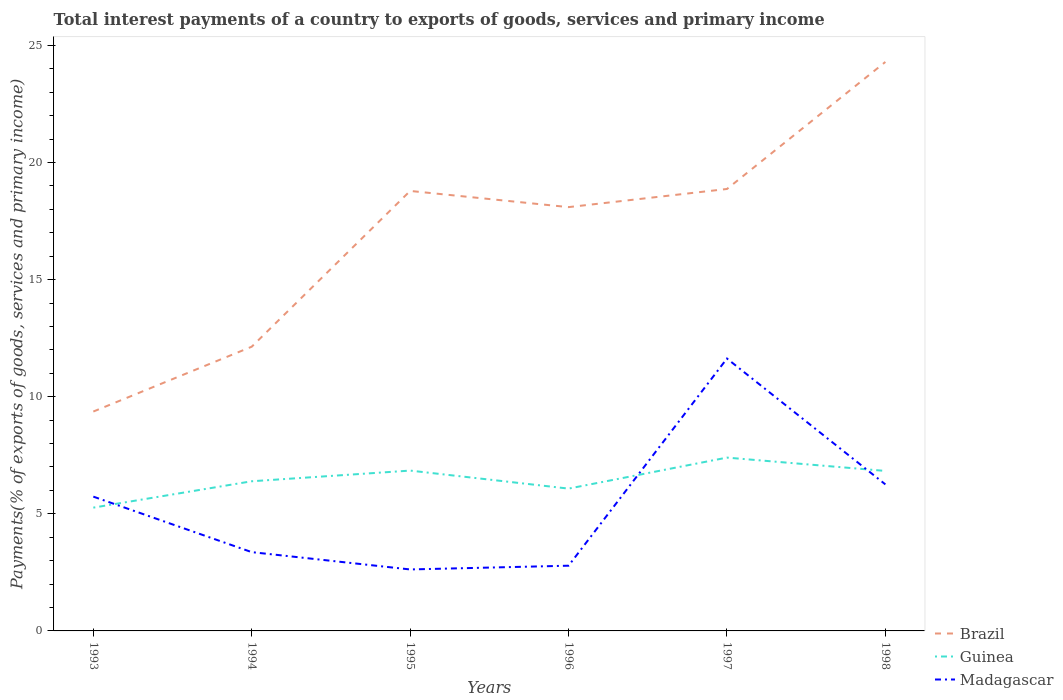Does the line corresponding to Brazil intersect with the line corresponding to Madagascar?
Provide a succinct answer. No. Is the number of lines equal to the number of legend labels?
Ensure brevity in your answer.  Yes. Across all years, what is the maximum total interest payments in Brazil?
Keep it short and to the point. 9.37. What is the total total interest payments in Guinea in the graph?
Your response must be concise. -1.13. What is the difference between the highest and the second highest total interest payments in Brazil?
Give a very brief answer. 14.93. How many lines are there?
Provide a short and direct response. 3. Does the graph contain grids?
Ensure brevity in your answer.  No. Where does the legend appear in the graph?
Provide a short and direct response. Bottom right. What is the title of the graph?
Your answer should be compact. Total interest payments of a country to exports of goods, services and primary income. What is the label or title of the Y-axis?
Your answer should be compact. Payments(% of exports of goods, services and primary income). What is the Payments(% of exports of goods, services and primary income) of Brazil in 1993?
Give a very brief answer. 9.37. What is the Payments(% of exports of goods, services and primary income) in Guinea in 1993?
Keep it short and to the point. 5.26. What is the Payments(% of exports of goods, services and primary income) of Madagascar in 1993?
Offer a very short reply. 5.73. What is the Payments(% of exports of goods, services and primary income) of Brazil in 1994?
Your answer should be very brief. 12.14. What is the Payments(% of exports of goods, services and primary income) of Guinea in 1994?
Keep it short and to the point. 6.39. What is the Payments(% of exports of goods, services and primary income) of Madagascar in 1994?
Provide a succinct answer. 3.36. What is the Payments(% of exports of goods, services and primary income) in Brazil in 1995?
Your answer should be very brief. 18.79. What is the Payments(% of exports of goods, services and primary income) in Guinea in 1995?
Your response must be concise. 6.85. What is the Payments(% of exports of goods, services and primary income) of Madagascar in 1995?
Your response must be concise. 2.62. What is the Payments(% of exports of goods, services and primary income) of Brazil in 1996?
Your answer should be very brief. 18.1. What is the Payments(% of exports of goods, services and primary income) of Guinea in 1996?
Give a very brief answer. 6.08. What is the Payments(% of exports of goods, services and primary income) in Madagascar in 1996?
Offer a very short reply. 2.78. What is the Payments(% of exports of goods, services and primary income) in Brazil in 1997?
Keep it short and to the point. 18.87. What is the Payments(% of exports of goods, services and primary income) of Guinea in 1997?
Offer a terse response. 7.4. What is the Payments(% of exports of goods, services and primary income) in Madagascar in 1997?
Ensure brevity in your answer.  11.63. What is the Payments(% of exports of goods, services and primary income) in Brazil in 1998?
Your response must be concise. 24.29. What is the Payments(% of exports of goods, services and primary income) in Guinea in 1998?
Keep it short and to the point. 6.83. What is the Payments(% of exports of goods, services and primary income) of Madagascar in 1998?
Make the answer very short. 6.26. Across all years, what is the maximum Payments(% of exports of goods, services and primary income) in Brazil?
Give a very brief answer. 24.29. Across all years, what is the maximum Payments(% of exports of goods, services and primary income) of Guinea?
Ensure brevity in your answer.  7.4. Across all years, what is the maximum Payments(% of exports of goods, services and primary income) in Madagascar?
Ensure brevity in your answer.  11.63. Across all years, what is the minimum Payments(% of exports of goods, services and primary income) of Brazil?
Offer a terse response. 9.37. Across all years, what is the minimum Payments(% of exports of goods, services and primary income) in Guinea?
Your answer should be compact. 5.26. Across all years, what is the minimum Payments(% of exports of goods, services and primary income) of Madagascar?
Offer a very short reply. 2.62. What is the total Payments(% of exports of goods, services and primary income) of Brazil in the graph?
Your answer should be very brief. 101.55. What is the total Payments(% of exports of goods, services and primary income) in Guinea in the graph?
Give a very brief answer. 38.81. What is the total Payments(% of exports of goods, services and primary income) of Madagascar in the graph?
Ensure brevity in your answer.  32.39. What is the difference between the Payments(% of exports of goods, services and primary income) in Brazil in 1993 and that in 1994?
Ensure brevity in your answer.  -2.77. What is the difference between the Payments(% of exports of goods, services and primary income) of Guinea in 1993 and that in 1994?
Your response must be concise. -1.13. What is the difference between the Payments(% of exports of goods, services and primary income) of Madagascar in 1993 and that in 1994?
Make the answer very short. 2.37. What is the difference between the Payments(% of exports of goods, services and primary income) in Brazil in 1993 and that in 1995?
Provide a short and direct response. -9.42. What is the difference between the Payments(% of exports of goods, services and primary income) of Guinea in 1993 and that in 1995?
Ensure brevity in your answer.  -1.58. What is the difference between the Payments(% of exports of goods, services and primary income) of Madagascar in 1993 and that in 1995?
Provide a short and direct response. 3.11. What is the difference between the Payments(% of exports of goods, services and primary income) in Brazil in 1993 and that in 1996?
Provide a short and direct response. -8.73. What is the difference between the Payments(% of exports of goods, services and primary income) in Guinea in 1993 and that in 1996?
Your response must be concise. -0.81. What is the difference between the Payments(% of exports of goods, services and primary income) in Madagascar in 1993 and that in 1996?
Your answer should be very brief. 2.95. What is the difference between the Payments(% of exports of goods, services and primary income) of Brazil in 1993 and that in 1997?
Offer a very short reply. -9.5. What is the difference between the Payments(% of exports of goods, services and primary income) of Guinea in 1993 and that in 1997?
Your answer should be very brief. -2.14. What is the difference between the Payments(% of exports of goods, services and primary income) in Madagascar in 1993 and that in 1997?
Keep it short and to the point. -5.9. What is the difference between the Payments(% of exports of goods, services and primary income) of Brazil in 1993 and that in 1998?
Provide a short and direct response. -14.93. What is the difference between the Payments(% of exports of goods, services and primary income) of Guinea in 1993 and that in 1998?
Your response must be concise. -1.57. What is the difference between the Payments(% of exports of goods, services and primary income) in Madagascar in 1993 and that in 1998?
Give a very brief answer. -0.52. What is the difference between the Payments(% of exports of goods, services and primary income) of Brazil in 1994 and that in 1995?
Your response must be concise. -6.65. What is the difference between the Payments(% of exports of goods, services and primary income) in Guinea in 1994 and that in 1995?
Give a very brief answer. -0.46. What is the difference between the Payments(% of exports of goods, services and primary income) of Madagascar in 1994 and that in 1995?
Ensure brevity in your answer.  0.74. What is the difference between the Payments(% of exports of goods, services and primary income) of Brazil in 1994 and that in 1996?
Offer a terse response. -5.96. What is the difference between the Payments(% of exports of goods, services and primary income) of Guinea in 1994 and that in 1996?
Your answer should be very brief. 0.31. What is the difference between the Payments(% of exports of goods, services and primary income) of Madagascar in 1994 and that in 1996?
Give a very brief answer. 0.58. What is the difference between the Payments(% of exports of goods, services and primary income) of Brazil in 1994 and that in 1997?
Offer a very short reply. -6.73. What is the difference between the Payments(% of exports of goods, services and primary income) of Guinea in 1994 and that in 1997?
Provide a short and direct response. -1.01. What is the difference between the Payments(% of exports of goods, services and primary income) in Madagascar in 1994 and that in 1997?
Provide a short and direct response. -8.27. What is the difference between the Payments(% of exports of goods, services and primary income) of Brazil in 1994 and that in 1998?
Your response must be concise. -12.16. What is the difference between the Payments(% of exports of goods, services and primary income) in Guinea in 1994 and that in 1998?
Provide a short and direct response. -0.44. What is the difference between the Payments(% of exports of goods, services and primary income) of Madagascar in 1994 and that in 1998?
Provide a short and direct response. -2.89. What is the difference between the Payments(% of exports of goods, services and primary income) in Brazil in 1995 and that in 1996?
Give a very brief answer. 0.69. What is the difference between the Payments(% of exports of goods, services and primary income) in Guinea in 1995 and that in 1996?
Give a very brief answer. 0.77. What is the difference between the Payments(% of exports of goods, services and primary income) in Madagascar in 1995 and that in 1996?
Make the answer very short. -0.16. What is the difference between the Payments(% of exports of goods, services and primary income) of Brazil in 1995 and that in 1997?
Your answer should be compact. -0.08. What is the difference between the Payments(% of exports of goods, services and primary income) of Guinea in 1995 and that in 1997?
Keep it short and to the point. -0.55. What is the difference between the Payments(% of exports of goods, services and primary income) in Madagascar in 1995 and that in 1997?
Your response must be concise. -9.01. What is the difference between the Payments(% of exports of goods, services and primary income) of Brazil in 1995 and that in 1998?
Offer a very short reply. -5.51. What is the difference between the Payments(% of exports of goods, services and primary income) in Guinea in 1995 and that in 1998?
Offer a terse response. 0.01. What is the difference between the Payments(% of exports of goods, services and primary income) in Madagascar in 1995 and that in 1998?
Provide a short and direct response. -3.63. What is the difference between the Payments(% of exports of goods, services and primary income) in Brazil in 1996 and that in 1997?
Your answer should be compact. -0.78. What is the difference between the Payments(% of exports of goods, services and primary income) in Guinea in 1996 and that in 1997?
Your answer should be compact. -1.32. What is the difference between the Payments(% of exports of goods, services and primary income) of Madagascar in 1996 and that in 1997?
Your answer should be compact. -8.85. What is the difference between the Payments(% of exports of goods, services and primary income) of Brazil in 1996 and that in 1998?
Make the answer very short. -6.2. What is the difference between the Payments(% of exports of goods, services and primary income) of Guinea in 1996 and that in 1998?
Keep it short and to the point. -0.75. What is the difference between the Payments(% of exports of goods, services and primary income) in Madagascar in 1996 and that in 1998?
Provide a succinct answer. -3.47. What is the difference between the Payments(% of exports of goods, services and primary income) in Brazil in 1997 and that in 1998?
Your answer should be compact. -5.42. What is the difference between the Payments(% of exports of goods, services and primary income) of Guinea in 1997 and that in 1998?
Give a very brief answer. 0.57. What is the difference between the Payments(% of exports of goods, services and primary income) in Madagascar in 1997 and that in 1998?
Provide a succinct answer. 5.37. What is the difference between the Payments(% of exports of goods, services and primary income) in Brazil in 1993 and the Payments(% of exports of goods, services and primary income) in Guinea in 1994?
Your answer should be very brief. 2.98. What is the difference between the Payments(% of exports of goods, services and primary income) of Brazil in 1993 and the Payments(% of exports of goods, services and primary income) of Madagascar in 1994?
Provide a short and direct response. 6. What is the difference between the Payments(% of exports of goods, services and primary income) in Guinea in 1993 and the Payments(% of exports of goods, services and primary income) in Madagascar in 1994?
Offer a terse response. 1.9. What is the difference between the Payments(% of exports of goods, services and primary income) of Brazil in 1993 and the Payments(% of exports of goods, services and primary income) of Guinea in 1995?
Offer a terse response. 2.52. What is the difference between the Payments(% of exports of goods, services and primary income) in Brazil in 1993 and the Payments(% of exports of goods, services and primary income) in Madagascar in 1995?
Your response must be concise. 6.74. What is the difference between the Payments(% of exports of goods, services and primary income) of Guinea in 1993 and the Payments(% of exports of goods, services and primary income) of Madagascar in 1995?
Make the answer very short. 2.64. What is the difference between the Payments(% of exports of goods, services and primary income) of Brazil in 1993 and the Payments(% of exports of goods, services and primary income) of Guinea in 1996?
Offer a very short reply. 3.29. What is the difference between the Payments(% of exports of goods, services and primary income) of Brazil in 1993 and the Payments(% of exports of goods, services and primary income) of Madagascar in 1996?
Provide a short and direct response. 6.58. What is the difference between the Payments(% of exports of goods, services and primary income) in Guinea in 1993 and the Payments(% of exports of goods, services and primary income) in Madagascar in 1996?
Offer a terse response. 2.48. What is the difference between the Payments(% of exports of goods, services and primary income) in Brazil in 1993 and the Payments(% of exports of goods, services and primary income) in Guinea in 1997?
Offer a terse response. 1.97. What is the difference between the Payments(% of exports of goods, services and primary income) in Brazil in 1993 and the Payments(% of exports of goods, services and primary income) in Madagascar in 1997?
Provide a short and direct response. -2.26. What is the difference between the Payments(% of exports of goods, services and primary income) in Guinea in 1993 and the Payments(% of exports of goods, services and primary income) in Madagascar in 1997?
Make the answer very short. -6.37. What is the difference between the Payments(% of exports of goods, services and primary income) of Brazil in 1993 and the Payments(% of exports of goods, services and primary income) of Guinea in 1998?
Your answer should be compact. 2.54. What is the difference between the Payments(% of exports of goods, services and primary income) in Brazil in 1993 and the Payments(% of exports of goods, services and primary income) in Madagascar in 1998?
Your answer should be compact. 3.11. What is the difference between the Payments(% of exports of goods, services and primary income) of Guinea in 1993 and the Payments(% of exports of goods, services and primary income) of Madagascar in 1998?
Make the answer very short. -0.99. What is the difference between the Payments(% of exports of goods, services and primary income) of Brazil in 1994 and the Payments(% of exports of goods, services and primary income) of Guinea in 1995?
Your answer should be compact. 5.29. What is the difference between the Payments(% of exports of goods, services and primary income) in Brazil in 1994 and the Payments(% of exports of goods, services and primary income) in Madagascar in 1995?
Provide a succinct answer. 9.51. What is the difference between the Payments(% of exports of goods, services and primary income) of Guinea in 1994 and the Payments(% of exports of goods, services and primary income) of Madagascar in 1995?
Your answer should be very brief. 3.77. What is the difference between the Payments(% of exports of goods, services and primary income) in Brazil in 1994 and the Payments(% of exports of goods, services and primary income) in Guinea in 1996?
Make the answer very short. 6.06. What is the difference between the Payments(% of exports of goods, services and primary income) of Brazil in 1994 and the Payments(% of exports of goods, services and primary income) of Madagascar in 1996?
Provide a short and direct response. 9.35. What is the difference between the Payments(% of exports of goods, services and primary income) in Guinea in 1994 and the Payments(% of exports of goods, services and primary income) in Madagascar in 1996?
Your answer should be very brief. 3.61. What is the difference between the Payments(% of exports of goods, services and primary income) in Brazil in 1994 and the Payments(% of exports of goods, services and primary income) in Guinea in 1997?
Give a very brief answer. 4.74. What is the difference between the Payments(% of exports of goods, services and primary income) of Brazil in 1994 and the Payments(% of exports of goods, services and primary income) of Madagascar in 1997?
Your answer should be very brief. 0.51. What is the difference between the Payments(% of exports of goods, services and primary income) in Guinea in 1994 and the Payments(% of exports of goods, services and primary income) in Madagascar in 1997?
Ensure brevity in your answer.  -5.24. What is the difference between the Payments(% of exports of goods, services and primary income) of Brazil in 1994 and the Payments(% of exports of goods, services and primary income) of Guinea in 1998?
Provide a succinct answer. 5.3. What is the difference between the Payments(% of exports of goods, services and primary income) in Brazil in 1994 and the Payments(% of exports of goods, services and primary income) in Madagascar in 1998?
Ensure brevity in your answer.  5.88. What is the difference between the Payments(% of exports of goods, services and primary income) in Guinea in 1994 and the Payments(% of exports of goods, services and primary income) in Madagascar in 1998?
Offer a terse response. 0.13. What is the difference between the Payments(% of exports of goods, services and primary income) in Brazil in 1995 and the Payments(% of exports of goods, services and primary income) in Guinea in 1996?
Ensure brevity in your answer.  12.71. What is the difference between the Payments(% of exports of goods, services and primary income) of Brazil in 1995 and the Payments(% of exports of goods, services and primary income) of Madagascar in 1996?
Your answer should be very brief. 16. What is the difference between the Payments(% of exports of goods, services and primary income) of Guinea in 1995 and the Payments(% of exports of goods, services and primary income) of Madagascar in 1996?
Offer a very short reply. 4.06. What is the difference between the Payments(% of exports of goods, services and primary income) in Brazil in 1995 and the Payments(% of exports of goods, services and primary income) in Guinea in 1997?
Keep it short and to the point. 11.39. What is the difference between the Payments(% of exports of goods, services and primary income) of Brazil in 1995 and the Payments(% of exports of goods, services and primary income) of Madagascar in 1997?
Provide a short and direct response. 7.16. What is the difference between the Payments(% of exports of goods, services and primary income) in Guinea in 1995 and the Payments(% of exports of goods, services and primary income) in Madagascar in 1997?
Give a very brief answer. -4.78. What is the difference between the Payments(% of exports of goods, services and primary income) in Brazil in 1995 and the Payments(% of exports of goods, services and primary income) in Guinea in 1998?
Ensure brevity in your answer.  11.96. What is the difference between the Payments(% of exports of goods, services and primary income) of Brazil in 1995 and the Payments(% of exports of goods, services and primary income) of Madagascar in 1998?
Your answer should be very brief. 12.53. What is the difference between the Payments(% of exports of goods, services and primary income) in Guinea in 1995 and the Payments(% of exports of goods, services and primary income) in Madagascar in 1998?
Provide a succinct answer. 0.59. What is the difference between the Payments(% of exports of goods, services and primary income) of Brazil in 1996 and the Payments(% of exports of goods, services and primary income) of Guinea in 1997?
Provide a short and direct response. 10.69. What is the difference between the Payments(% of exports of goods, services and primary income) in Brazil in 1996 and the Payments(% of exports of goods, services and primary income) in Madagascar in 1997?
Ensure brevity in your answer.  6.47. What is the difference between the Payments(% of exports of goods, services and primary income) in Guinea in 1996 and the Payments(% of exports of goods, services and primary income) in Madagascar in 1997?
Your response must be concise. -5.55. What is the difference between the Payments(% of exports of goods, services and primary income) of Brazil in 1996 and the Payments(% of exports of goods, services and primary income) of Guinea in 1998?
Make the answer very short. 11.26. What is the difference between the Payments(% of exports of goods, services and primary income) in Brazil in 1996 and the Payments(% of exports of goods, services and primary income) in Madagascar in 1998?
Your response must be concise. 11.84. What is the difference between the Payments(% of exports of goods, services and primary income) of Guinea in 1996 and the Payments(% of exports of goods, services and primary income) of Madagascar in 1998?
Give a very brief answer. -0.18. What is the difference between the Payments(% of exports of goods, services and primary income) of Brazil in 1997 and the Payments(% of exports of goods, services and primary income) of Guinea in 1998?
Offer a terse response. 12.04. What is the difference between the Payments(% of exports of goods, services and primary income) in Brazil in 1997 and the Payments(% of exports of goods, services and primary income) in Madagascar in 1998?
Provide a succinct answer. 12.61. What is the difference between the Payments(% of exports of goods, services and primary income) of Guinea in 1997 and the Payments(% of exports of goods, services and primary income) of Madagascar in 1998?
Keep it short and to the point. 1.14. What is the average Payments(% of exports of goods, services and primary income) in Brazil per year?
Provide a succinct answer. 16.92. What is the average Payments(% of exports of goods, services and primary income) of Guinea per year?
Give a very brief answer. 6.47. What is the average Payments(% of exports of goods, services and primary income) in Madagascar per year?
Make the answer very short. 5.4. In the year 1993, what is the difference between the Payments(% of exports of goods, services and primary income) of Brazil and Payments(% of exports of goods, services and primary income) of Guinea?
Your answer should be very brief. 4.1. In the year 1993, what is the difference between the Payments(% of exports of goods, services and primary income) in Brazil and Payments(% of exports of goods, services and primary income) in Madagascar?
Offer a very short reply. 3.63. In the year 1993, what is the difference between the Payments(% of exports of goods, services and primary income) of Guinea and Payments(% of exports of goods, services and primary income) of Madagascar?
Offer a very short reply. -0.47. In the year 1994, what is the difference between the Payments(% of exports of goods, services and primary income) in Brazil and Payments(% of exports of goods, services and primary income) in Guinea?
Offer a very short reply. 5.75. In the year 1994, what is the difference between the Payments(% of exports of goods, services and primary income) in Brazil and Payments(% of exports of goods, services and primary income) in Madagascar?
Keep it short and to the point. 8.77. In the year 1994, what is the difference between the Payments(% of exports of goods, services and primary income) of Guinea and Payments(% of exports of goods, services and primary income) of Madagascar?
Your answer should be very brief. 3.03. In the year 1995, what is the difference between the Payments(% of exports of goods, services and primary income) of Brazil and Payments(% of exports of goods, services and primary income) of Guinea?
Your answer should be compact. 11.94. In the year 1995, what is the difference between the Payments(% of exports of goods, services and primary income) in Brazil and Payments(% of exports of goods, services and primary income) in Madagascar?
Ensure brevity in your answer.  16.16. In the year 1995, what is the difference between the Payments(% of exports of goods, services and primary income) in Guinea and Payments(% of exports of goods, services and primary income) in Madagascar?
Offer a very short reply. 4.22. In the year 1996, what is the difference between the Payments(% of exports of goods, services and primary income) of Brazil and Payments(% of exports of goods, services and primary income) of Guinea?
Give a very brief answer. 12.02. In the year 1996, what is the difference between the Payments(% of exports of goods, services and primary income) in Brazil and Payments(% of exports of goods, services and primary income) in Madagascar?
Give a very brief answer. 15.31. In the year 1996, what is the difference between the Payments(% of exports of goods, services and primary income) of Guinea and Payments(% of exports of goods, services and primary income) of Madagascar?
Offer a terse response. 3.29. In the year 1997, what is the difference between the Payments(% of exports of goods, services and primary income) of Brazil and Payments(% of exports of goods, services and primary income) of Guinea?
Your response must be concise. 11.47. In the year 1997, what is the difference between the Payments(% of exports of goods, services and primary income) of Brazil and Payments(% of exports of goods, services and primary income) of Madagascar?
Your answer should be compact. 7.24. In the year 1997, what is the difference between the Payments(% of exports of goods, services and primary income) of Guinea and Payments(% of exports of goods, services and primary income) of Madagascar?
Ensure brevity in your answer.  -4.23. In the year 1998, what is the difference between the Payments(% of exports of goods, services and primary income) in Brazil and Payments(% of exports of goods, services and primary income) in Guinea?
Your answer should be compact. 17.46. In the year 1998, what is the difference between the Payments(% of exports of goods, services and primary income) in Brazil and Payments(% of exports of goods, services and primary income) in Madagascar?
Provide a short and direct response. 18.04. In the year 1998, what is the difference between the Payments(% of exports of goods, services and primary income) in Guinea and Payments(% of exports of goods, services and primary income) in Madagascar?
Provide a short and direct response. 0.58. What is the ratio of the Payments(% of exports of goods, services and primary income) of Brazil in 1993 to that in 1994?
Ensure brevity in your answer.  0.77. What is the ratio of the Payments(% of exports of goods, services and primary income) of Guinea in 1993 to that in 1994?
Your response must be concise. 0.82. What is the ratio of the Payments(% of exports of goods, services and primary income) of Madagascar in 1993 to that in 1994?
Provide a succinct answer. 1.7. What is the ratio of the Payments(% of exports of goods, services and primary income) of Brazil in 1993 to that in 1995?
Give a very brief answer. 0.5. What is the ratio of the Payments(% of exports of goods, services and primary income) of Guinea in 1993 to that in 1995?
Give a very brief answer. 0.77. What is the ratio of the Payments(% of exports of goods, services and primary income) of Madagascar in 1993 to that in 1995?
Your answer should be compact. 2.18. What is the ratio of the Payments(% of exports of goods, services and primary income) in Brazil in 1993 to that in 1996?
Offer a terse response. 0.52. What is the ratio of the Payments(% of exports of goods, services and primary income) of Guinea in 1993 to that in 1996?
Give a very brief answer. 0.87. What is the ratio of the Payments(% of exports of goods, services and primary income) in Madagascar in 1993 to that in 1996?
Ensure brevity in your answer.  2.06. What is the ratio of the Payments(% of exports of goods, services and primary income) in Brazil in 1993 to that in 1997?
Offer a very short reply. 0.5. What is the ratio of the Payments(% of exports of goods, services and primary income) in Guinea in 1993 to that in 1997?
Provide a succinct answer. 0.71. What is the ratio of the Payments(% of exports of goods, services and primary income) of Madagascar in 1993 to that in 1997?
Provide a short and direct response. 0.49. What is the ratio of the Payments(% of exports of goods, services and primary income) in Brazil in 1993 to that in 1998?
Make the answer very short. 0.39. What is the ratio of the Payments(% of exports of goods, services and primary income) in Guinea in 1993 to that in 1998?
Offer a very short reply. 0.77. What is the ratio of the Payments(% of exports of goods, services and primary income) in Madagascar in 1993 to that in 1998?
Ensure brevity in your answer.  0.92. What is the ratio of the Payments(% of exports of goods, services and primary income) in Brazil in 1994 to that in 1995?
Keep it short and to the point. 0.65. What is the ratio of the Payments(% of exports of goods, services and primary income) of Guinea in 1994 to that in 1995?
Your answer should be very brief. 0.93. What is the ratio of the Payments(% of exports of goods, services and primary income) of Madagascar in 1994 to that in 1995?
Your answer should be very brief. 1.28. What is the ratio of the Payments(% of exports of goods, services and primary income) in Brazil in 1994 to that in 1996?
Your answer should be compact. 0.67. What is the ratio of the Payments(% of exports of goods, services and primary income) in Guinea in 1994 to that in 1996?
Give a very brief answer. 1.05. What is the ratio of the Payments(% of exports of goods, services and primary income) of Madagascar in 1994 to that in 1996?
Provide a short and direct response. 1.21. What is the ratio of the Payments(% of exports of goods, services and primary income) in Brazil in 1994 to that in 1997?
Give a very brief answer. 0.64. What is the ratio of the Payments(% of exports of goods, services and primary income) in Guinea in 1994 to that in 1997?
Provide a short and direct response. 0.86. What is the ratio of the Payments(% of exports of goods, services and primary income) of Madagascar in 1994 to that in 1997?
Give a very brief answer. 0.29. What is the ratio of the Payments(% of exports of goods, services and primary income) in Brazil in 1994 to that in 1998?
Ensure brevity in your answer.  0.5. What is the ratio of the Payments(% of exports of goods, services and primary income) of Guinea in 1994 to that in 1998?
Offer a very short reply. 0.94. What is the ratio of the Payments(% of exports of goods, services and primary income) in Madagascar in 1994 to that in 1998?
Keep it short and to the point. 0.54. What is the ratio of the Payments(% of exports of goods, services and primary income) in Brazil in 1995 to that in 1996?
Offer a terse response. 1.04. What is the ratio of the Payments(% of exports of goods, services and primary income) of Guinea in 1995 to that in 1996?
Provide a succinct answer. 1.13. What is the ratio of the Payments(% of exports of goods, services and primary income) of Madagascar in 1995 to that in 1996?
Keep it short and to the point. 0.94. What is the ratio of the Payments(% of exports of goods, services and primary income) of Guinea in 1995 to that in 1997?
Provide a succinct answer. 0.93. What is the ratio of the Payments(% of exports of goods, services and primary income) in Madagascar in 1995 to that in 1997?
Provide a succinct answer. 0.23. What is the ratio of the Payments(% of exports of goods, services and primary income) of Brazil in 1995 to that in 1998?
Keep it short and to the point. 0.77. What is the ratio of the Payments(% of exports of goods, services and primary income) in Madagascar in 1995 to that in 1998?
Your answer should be compact. 0.42. What is the ratio of the Payments(% of exports of goods, services and primary income) of Brazil in 1996 to that in 1997?
Provide a succinct answer. 0.96. What is the ratio of the Payments(% of exports of goods, services and primary income) of Guinea in 1996 to that in 1997?
Your answer should be compact. 0.82. What is the ratio of the Payments(% of exports of goods, services and primary income) in Madagascar in 1996 to that in 1997?
Provide a succinct answer. 0.24. What is the ratio of the Payments(% of exports of goods, services and primary income) in Brazil in 1996 to that in 1998?
Your response must be concise. 0.74. What is the ratio of the Payments(% of exports of goods, services and primary income) of Guinea in 1996 to that in 1998?
Your response must be concise. 0.89. What is the ratio of the Payments(% of exports of goods, services and primary income) of Madagascar in 1996 to that in 1998?
Provide a short and direct response. 0.45. What is the ratio of the Payments(% of exports of goods, services and primary income) in Brazil in 1997 to that in 1998?
Make the answer very short. 0.78. What is the ratio of the Payments(% of exports of goods, services and primary income) of Madagascar in 1997 to that in 1998?
Provide a succinct answer. 1.86. What is the difference between the highest and the second highest Payments(% of exports of goods, services and primary income) of Brazil?
Make the answer very short. 5.42. What is the difference between the highest and the second highest Payments(% of exports of goods, services and primary income) in Guinea?
Your response must be concise. 0.55. What is the difference between the highest and the second highest Payments(% of exports of goods, services and primary income) of Madagascar?
Provide a succinct answer. 5.37. What is the difference between the highest and the lowest Payments(% of exports of goods, services and primary income) in Brazil?
Your answer should be compact. 14.93. What is the difference between the highest and the lowest Payments(% of exports of goods, services and primary income) in Guinea?
Offer a terse response. 2.14. What is the difference between the highest and the lowest Payments(% of exports of goods, services and primary income) in Madagascar?
Make the answer very short. 9.01. 